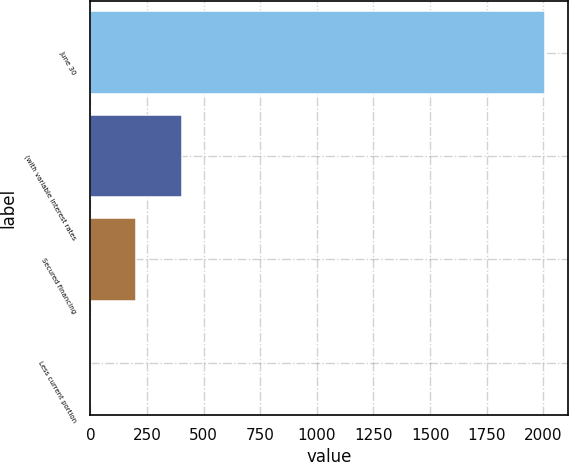Convert chart to OTSL. <chart><loc_0><loc_0><loc_500><loc_500><bar_chart><fcel>June 30<fcel>(with variable interest rates<fcel>Secured financing<fcel>Less current portion<nl><fcel>2009<fcel>404.04<fcel>203.42<fcel>2.8<nl></chart> 